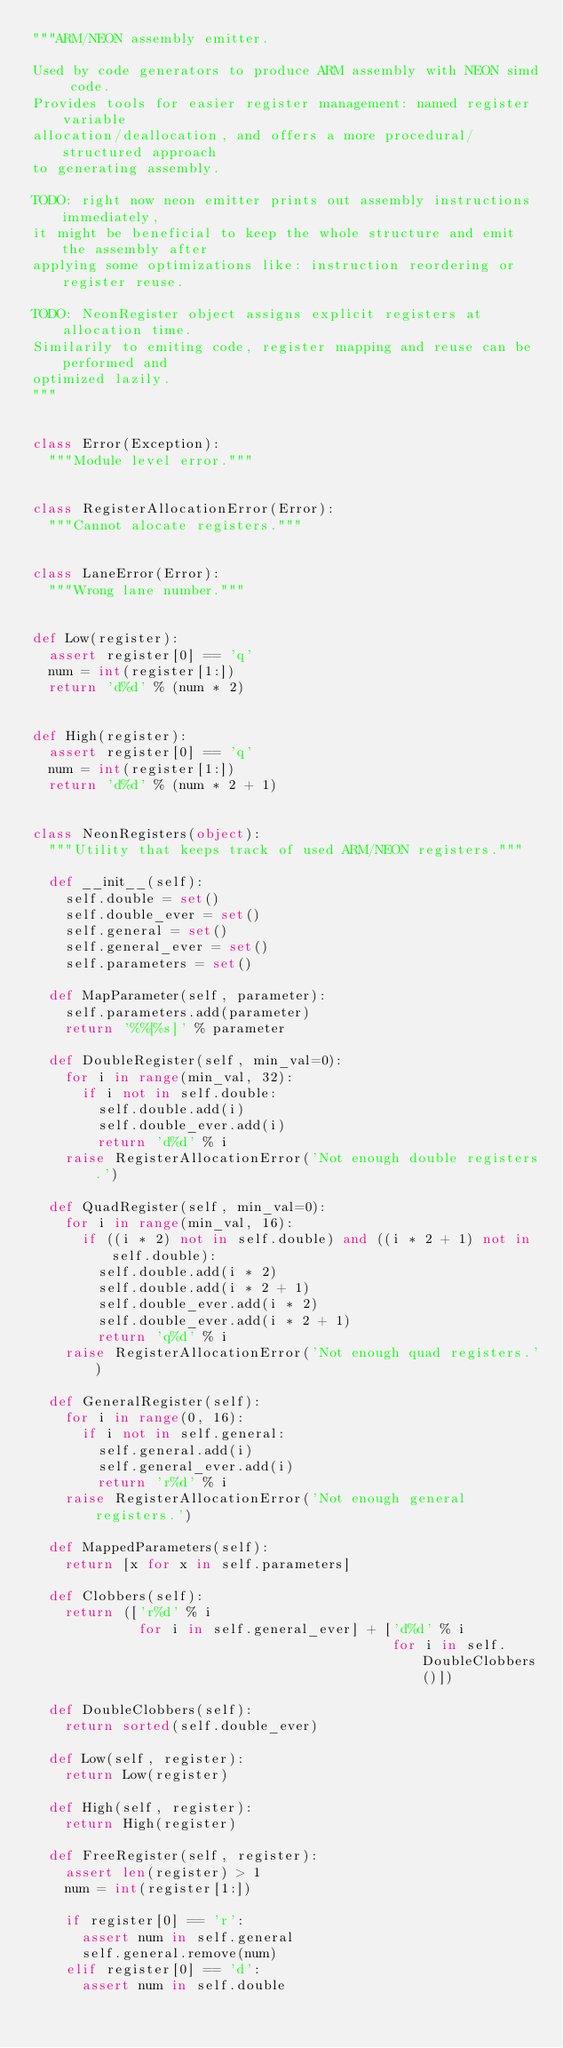<code> <loc_0><loc_0><loc_500><loc_500><_Python_>"""ARM/NEON assembly emitter.

Used by code generators to produce ARM assembly with NEON simd code.
Provides tools for easier register management: named register variable
allocation/deallocation, and offers a more procedural/structured approach
to generating assembly.

TODO: right now neon emitter prints out assembly instructions immediately,
it might be beneficial to keep the whole structure and emit the assembly after
applying some optimizations like: instruction reordering or register reuse.

TODO: NeonRegister object assigns explicit registers at allocation time.
Similarily to emiting code, register mapping and reuse can be performed and
optimized lazily.
"""


class Error(Exception):
  """Module level error."""


class RegisterAllocationError(Error):
  """Cannot alocate registers."""


class LaneError(Error):
  """Wrong lane number."""


def Low(register):
  assert register[0] == 'q'
  num = int(register[1:])
  return 'd%d' % (num * 2)


def High(register):
  assert register[0] == 'q'
  num = int(register[1:])
  return 'd%d' % (num * 2 + 1)


class NeonRegisters(object):
  """Utility that keeps track of used ARM/NEON registers."""

  def __init__(self):
    self.double = set()
    self.double_ever = set()
    self.general = set()
    self.general_ever = set()
    self.parameters = set()

  def MapParameter(self, parameter):
    self.parameters.add(parameter)
    return '%%[%s]' % parameter

  def DoubleRegister(self, min_val=0):
    for i in range(min_val, 32):
      if i not in self.double:
        self.double.add(i)
        self.double_ever.add(i)
        return 'd%d' % i
    raise RegisterAllocationError('Not enough double registers.')

  def QuadRegister(self, min_val=0):
    for i in range(min_val, 16):
      if ((i * 2) not in self.double) and ((i * 2 + 1) not in self.double):
        self.double.add(i * 2)
        self.double.add(i * 2 + 1)
        self.double_ever.add(i * 2)
        self.double_ever.add(i * 2 + 1)
        return 'q%d' % i
    raise RegisterAllocationError('Not enough quad registers.')

  def GeneralRegister(self):
    for i in range(0, 16):
      if i not in self.general:
        self.general.add(i)
        self.general_ever.add(i)
        return 'r%d' % i
    raise RegisterAllocationError('Not enough general registers.')

  def MappedParameters(self):
    return [x for x in self.parameters]

  def Clobbers(self):
    return (['r%d' % i
             for i in self.general_ever] + ['d%d' % i
                                            for i in self.DoubleClobbers()])

  def DoubleClobbers(self):
    return sorted(self.double_ever)

  def Low(self, register):
    return Low(register)

  def High(self, register):
    return High(register)

  def FreeRegister(self, register):
    assert len(register) > 1
    num = int(register[1:])

    if register[0] == 'r':
      assert num in self.general
      self.general.remove(num)
    elif register[0] == 'd':
      assert num in self.double</code> 